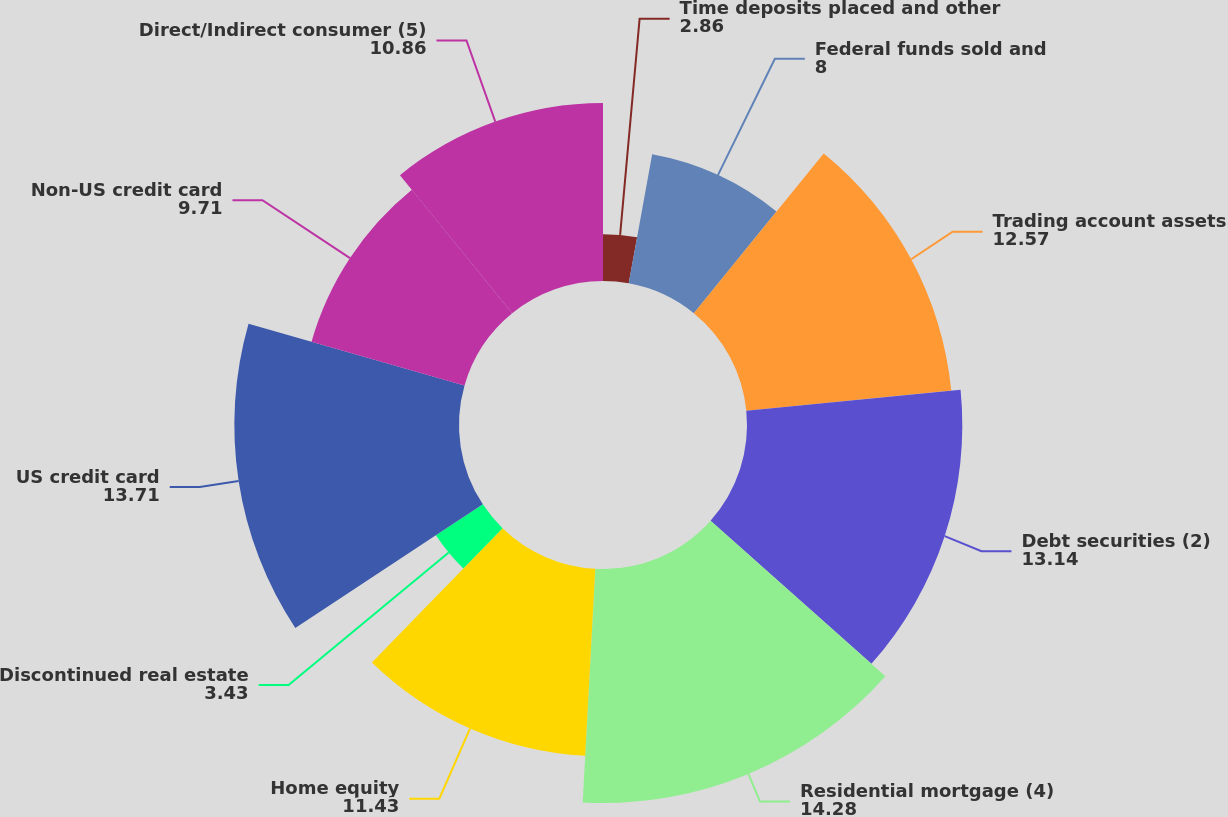<chart> <loc_0><loc_0><loc_500><loc_500><pie_chart><fcel>Time deposits placed and other<fcel>Federal funds sold and<fcel>Trading account assets<fcel>Debt securities (2)<fcel>Residential mortgage (4)<fcel>Home equity<fcel>Discontinued real estate<fcel>US credit card<fcel>Non-US credit card<fcel>Direct/Indirect consumer (5)<nl><fcel>2.86%<fcel>8.0%<fcel>12.57%<fcel>13.14%<fcel>14.28%<fcel>11.43%<fcel>3.43%<fcel>13.71%<fcel>9.71%<fcel>10.86%<nl></chart> 